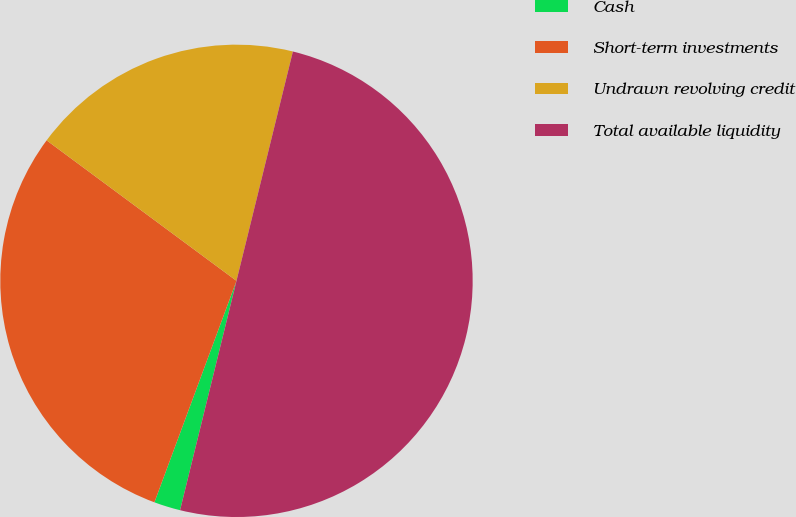Convert chart. <chart><loc_0><loc_0><loc_500><loc_500><pie_chart><fcel>Cash<fcel>Short-term investments<fcel>Undrawn revolving credit<fcel>Total available liquidity<nl><fcel>1.81%<fcel>29.49%<fcel>18.7%<fcel>50.0%<nl></chart> 